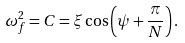Convert formula to latex. <formula><loc_0><loc_0><loc_500><loc_500>\omega _ { f } ^ { 2 } = C = \xi \cos \left ( \psi + \frac { \pi } { N } \right ) .</formula> 